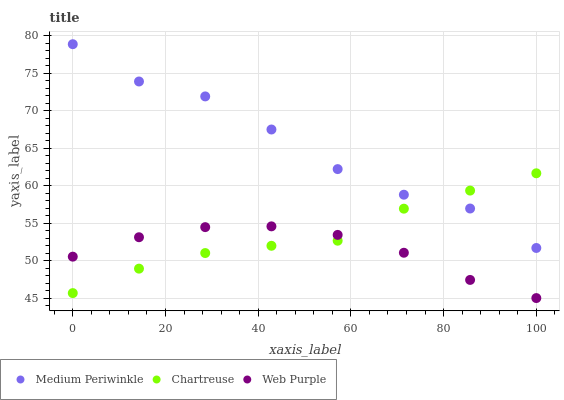Does Web Purple have the minimum area under the curve?
Answer yes or no. Yes. Does Medium Periwinkle have the maximum area under the curve?
Answer yes or no. Yes. Does Medium Periwinkle have the minimum area under the curve?
Answer yes or no. No. Does Web Purple have the maximum area under the curve?
Answer yes or no. No. Is Web Purple the smoothest?
Answer yes or no. Yes. Is Medium Periwinkle the roughest?
Answer yes or no. Yes. Is Medium Periwinkle the smoothest?
Answer yes or no. No. Is Web Purple the roughest?
Answer yes or no. No. Does Web Purple have the lowest value?
Answer yes or no. Yes. Does Medium Periwinkle have the lowest value?
Answer yes or no. No. Does Medium Periwinkle have the highest value?
Answer yes or no. Yes. Does Web Purple have the highest value?
Answer yes or no. No. Is Web Purple less than Medium Periwinkle?
Answer yes or no. Yes. Is Medium Periwinkle greater than Web Purple?
Answer yes or no. Yes. Does Medium Periwinkle intersect Chartreuse?
Answer yes or no. Yes. Is Medium Periwinkle less than Chartreuse?
Answer yes or no. No. Is Medium Periwinkle greater than Chartreuse?
Answer yes or no. No. Does Web Purple intersect Medium Periwinkle?
Answer yes or no. No. 